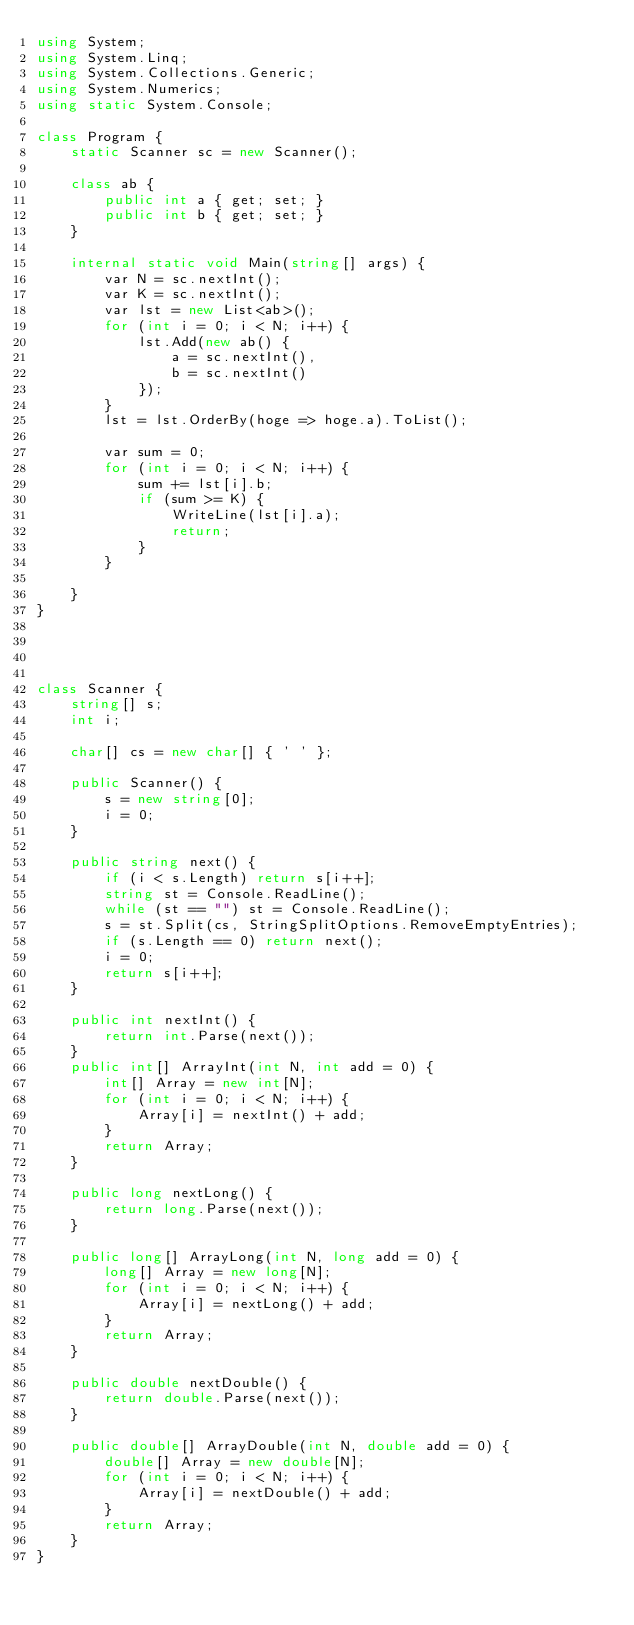<code> <loc_0><loc_0><loc_500><loc_500><_C#_>using System;
using System.Linq;
using System.Collections.Generic;
using System.Numerics;
using static System.Console;

class Program {
    static Scanner sc = new Scanner();

    class ab {
        public int a { get; set; }
        public int b { get; set; }
    }

    internal static void Main(string[] args) {
        var N = sc.nextInt();
        var K = sc.nextInt();
        var lst = new List<ab>();
        for (int i = 0; i < N; i++) {
            lst.Add(new ab() {
                a = sc.nextInt(),
                b = sc.nextInt()
            });
        }
        lst = lst.OrderBy(hoge => hoge.a).ToList();

        var sum = 0;
        for (int i = 0; i < N; i++) {
            sum += lst[i].b;
            if (sum >= K) {
                WriteLine(lst[i].a);
                return;
            }
        }

    }
}




class Scanner {
    string[] s;
    int i;

    char[] cs = new char[] { ' ' };

    public Scanner() {
        s = new string[0];
        i = 0;
    }

    public string next() {
        if (i < s.Length) return s[i++];
        string st = Console.ReadLine();
        while (st == "") st = Console.ReadLine();
        s = st.Split(cs, StringSplitOptions.RemoveEmptyEntries);
        if (s.Length == 0) return next();
        i = 0;
        return s[i++];
    }

    public int nextInt() {
        return int.Parse(next());
    }
    public int[] ArrayInt(int N, int add = 0) {
        int[] Array = new int[N];
        for (int i = 0; i < N; i++) {
            Array[i] = nextInt() + add;
        }
        return Array;
    }

    public long nextLong() {
        return long.Parse(next());
    }

    public long[] ArrayLong(int N, long add = 0) {
        long[] Array = new long[N];
        for (int i = 0; i < N; i++) {
            Array[i] = nextLong() + add;
        }
        return Array;
    }

    public double nextDouble() {
        return double.Parse(next());
    }

    public double[] ArrayDouble(int N, double add = 0) {
        double[] Array = new double[N];
        for (int i = 0; i < N; i++) {
            Array[i] = nextDouble() + add;
        }
        return Array;
    }
}
</code> 